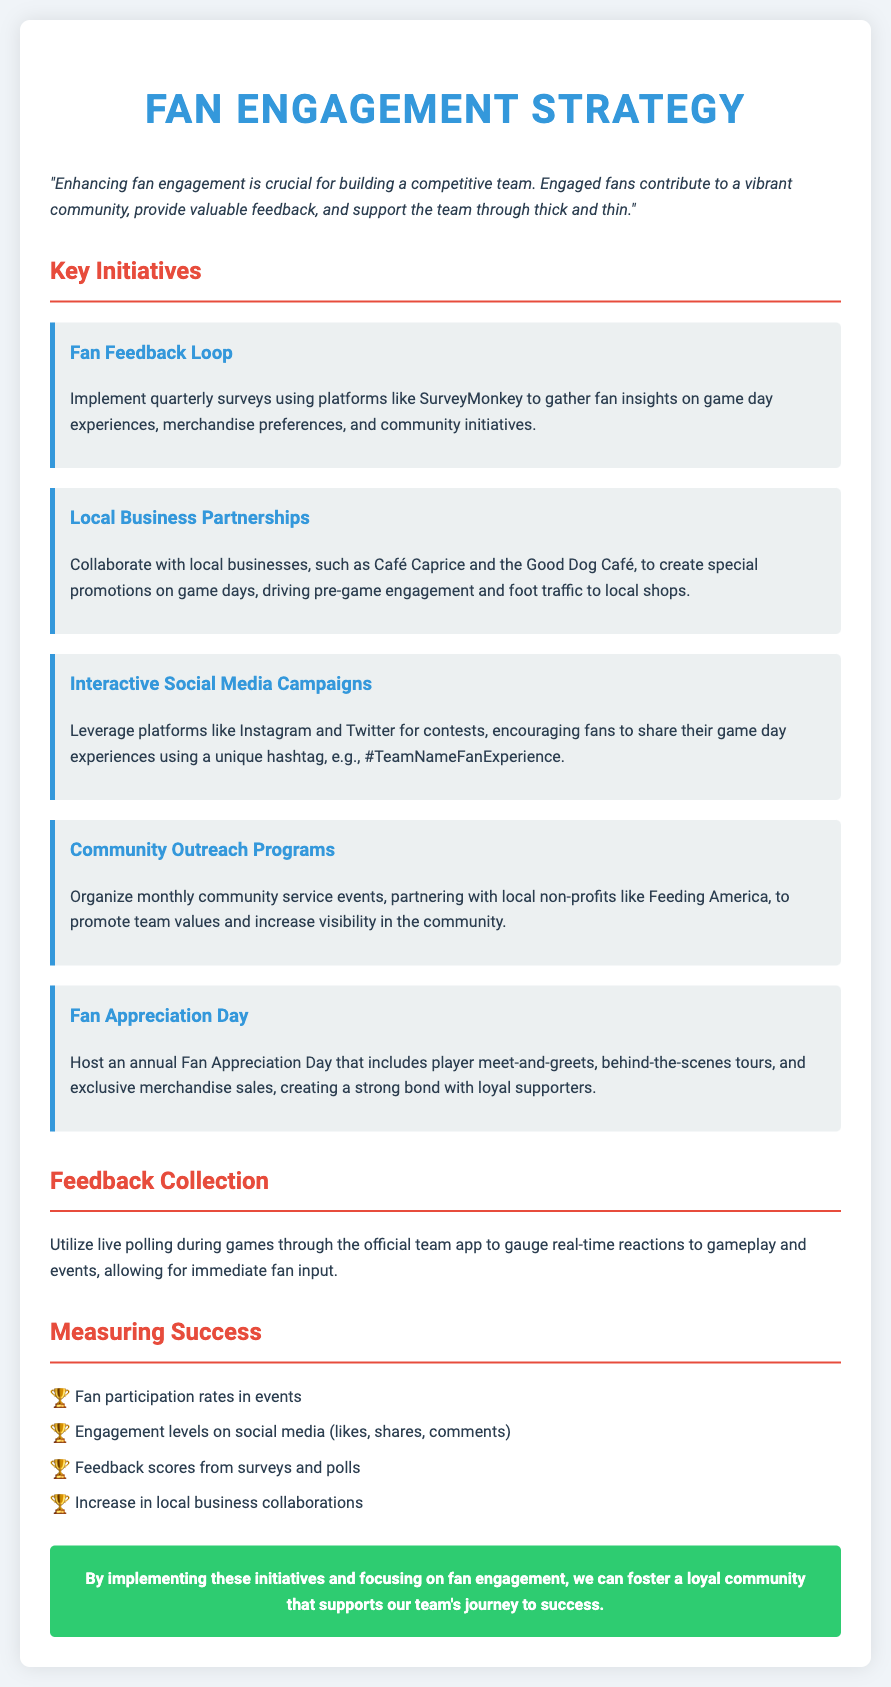What is the title of the document? The title of the document is stated as "Fan Engagement Strategy."
Answer: Fan Engagement Strategy What is one platform mentioned for gathering fan insights? The document mentions "SurveyMonkey" as a platform for polls.
Answer: SurveyMonkey How often will the fan feedback loop occur? The document specifies that the fan feedback loop will be implemented quarterly.
Answer: Quarterly Name one local business mentioned for collaboration on game days. The document lists "Café Caprice" as one of the local businesses for partnership.
Answer: Café Caprice What event is hosted annually to appreciate fans? The document states that an annual event called "Fan Appreciation Day" is hosted.
Answer: Fan Appreciation Day Which program partners with local non-profits for community service? The document refers to "Community Outreach Programs" involving local non-profits like Feeding America.
Answer: Community Outreach Programs How will success be measured in social media? The document states that engagement levels on social media will be tracked through metrics such as likes and shares.
Answer: Likes and shares What initiative encourages fans to share experiences using a hashtag? "Interactive Social Media Campaigns" is the initiative that encourages sharing experiences using a unique hashtag.
Answer: Interactive Social Media Campaigns What color is used for the conclusion section? The document describes the conclusion section's background color as green.
Answer: Green 